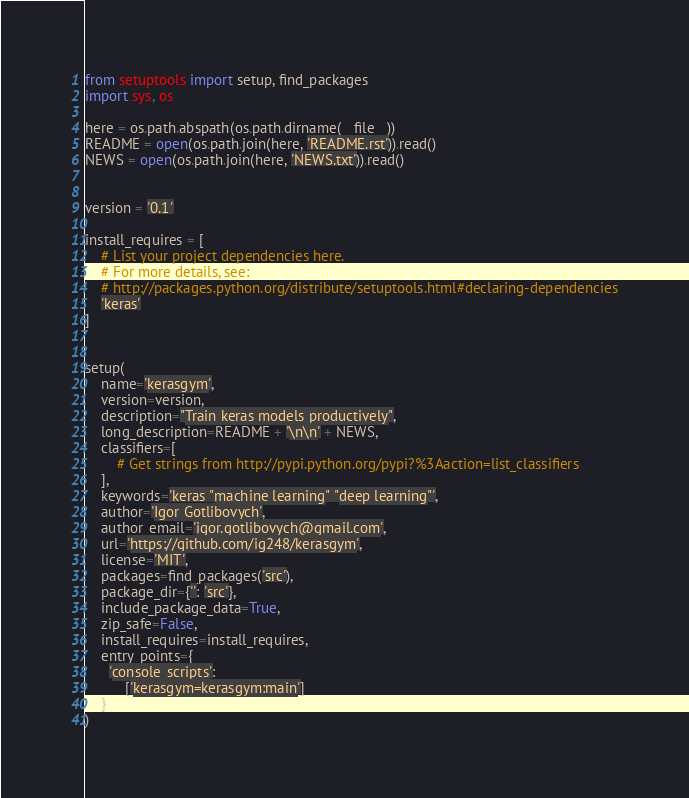<code> <loc_0><loc_0><loc_500><loc_500><_Python_>from setuptools import setup, find_packages
import sys, os

here = os.path.abspath(os.path.dirname(__file__))
README = open(os.path.join(here, 'README.rst')).read()
NEWS = open(os.path.join(here, 'NEWS.txt')).read()


version = '0.1'

install_requires = [
    # List your project dependencies here.
    # For more details, see:
    # http://packages.python.org/distribute/setuptools.html#declaring-dependencies
    'keras'
]


setup(
    name='kerasgym',
    version=version,
    description="Train keras models productively",
    long_description=README + '\n\n' + NEWS,
    classifiers=[
        # Get strings from http://pypi.python.org/pypi?%3Aaction=list_classifiers
    ],
    keywords='keras "machine learning" "deep learning"',
    author='Igor Gotlibovych',
    author_email='igor.gotlibovych@gmail.com',
    url='https://github.com/ig248/kerasgym',
    license='MIT',
    packages=find_packages('src'),
    package_dir={'': 'src'},
    include_package_data=True,
    zip_safe=False,
    install_requires=install_requires,
    entry_points={
      'console_scripts':
          ['kerasgym=kerasgym:main']
    }
)
</code> 